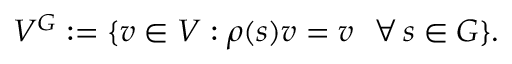<formula> <loc_0><loc_0><loc_500><loc_500>V ^ { G } \colon = \{ v \in V \colon \rho ( s ) v = v \, \forall \, s \in G \} .</formula> 